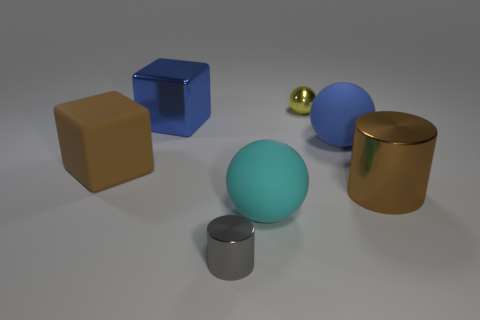What is the size of the matte object that is the same color as the metal block?
Offer a very short reply. Large. What size is the other thing that is the same shape as the large brown shiny object?
Offer a very short reply. Small. What material is the cylinder that is the same color as the matte block?
Ensure brevity in your answer.  Metal. Are there more large cylinders than big yellow rubber cubes?
Provide a short and direct response. Yes. There is a cylinder on the right side of the gray cylinder; is its size the same as the cyan sphere on the right side of the gray object?
Provide a succinct answer. Yes. How many objects are both on the right side of the blue cube and behind the tiny gray object?
Offer a terse response. 4. There is another large thing that is the same shape as the brown matte thing; what is its color?
Your answer should be compact. Blue. Are there fewer big objects than cyan matte spheres?
Make the answer very short. No. There is a gray cylinder; is it the same size as the ball that is in front of the blue matte thing?
Provide a short and direct response. No. What is the color of the small object behind the big matte object that is on the left side of the cyan rubber object?
Your answer should be compact. Yellow. 